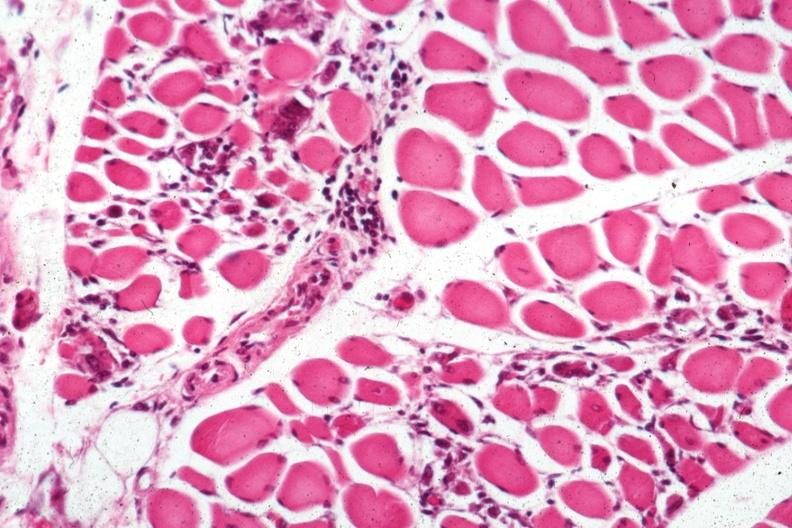s soft tissue present?
Answer the question using a single word or phrase. Yes 